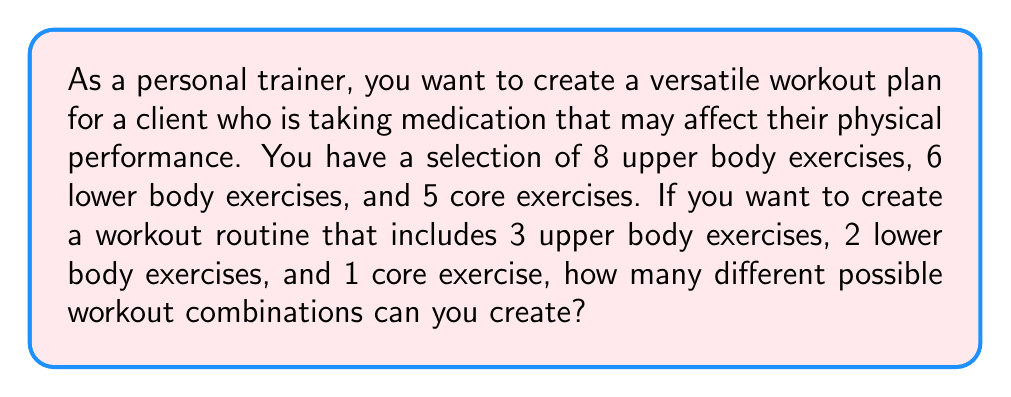Solve this math problem. To solve this problem, we need to use the multiplication principle of counting and combinations. Let's break it down step by step:

1. Upper body exercises:
   We need to choose 3 exercises out of 8 available. This is a combination problem.
   The number of ways to choose 3 from 8 is denoted as $\binom{8}{3}$ and calculated as:
   $$\binom{8}{3} = \frac{8!}{3!(8-3)!} = \frac{8!}{3!5!} = 56$$

2. Lower body exercises:
   We need to choose 2 exercises out of 6 available.
   The number of ways to choose 2 from 6 is:
   $$\binom{6}{2} = \frac{6!}{2!(6-2)!} = \frac{6!}{2!4!} = 15$$

3. Core exercises:
   We need to choose 1 exercise out of 5 available.
   The number of ways to choose 1 from 5 is:
   $$\binom{5}{1} = \frac{5!}{1!(5-1)!} = \frac{5!}{1!4!} = 5$$

4. To get the total number of possible workout combinations, we multiply these results together:
   $$56 \times 15 \times 5 = 4,200$$

This multiplication is valid because for each choice of upper body exercises, we can independently choose any combination of lower body and core exercises, and vice versa.
Answer: There are 4,200 different possible workout combinations. 